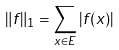<formula> <loc_0><loc_0><loc_500><loc_500>\| f \| _ { 1 } = \sum _ { x \in E } | f ( x ) |</formula> 